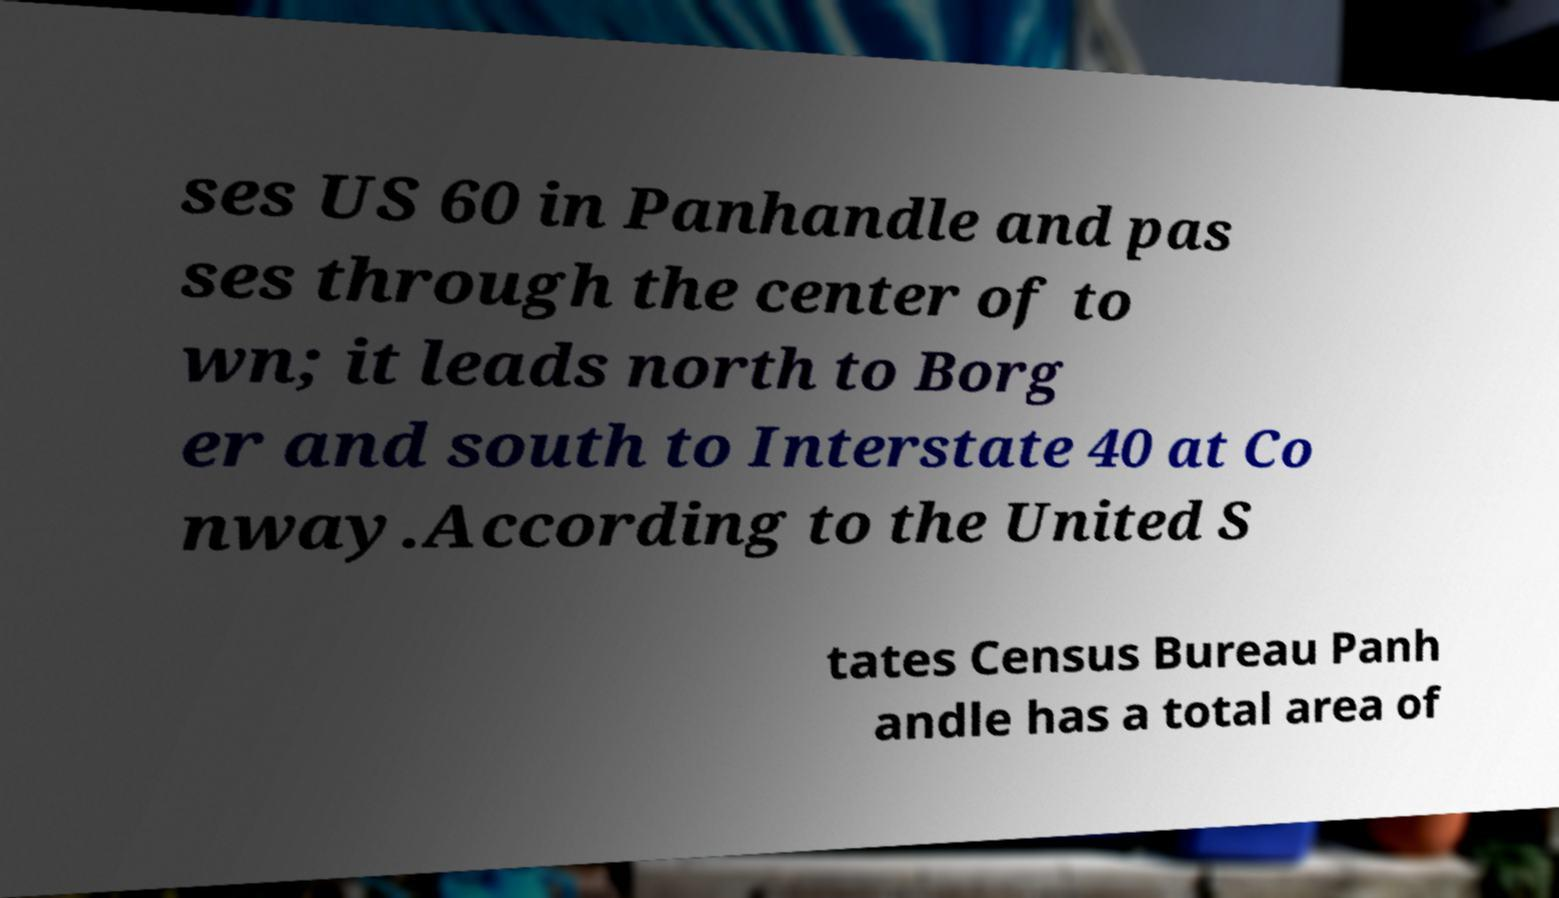Can you accurately transcribe the text from the provided image for me? ses US 60 in Panhandle and pas ses through the center of to wn; it leads north to Borg er and south to Interstate 40 at Co nway.According to the United S tates Census Bureau Panh andle has a total area of 